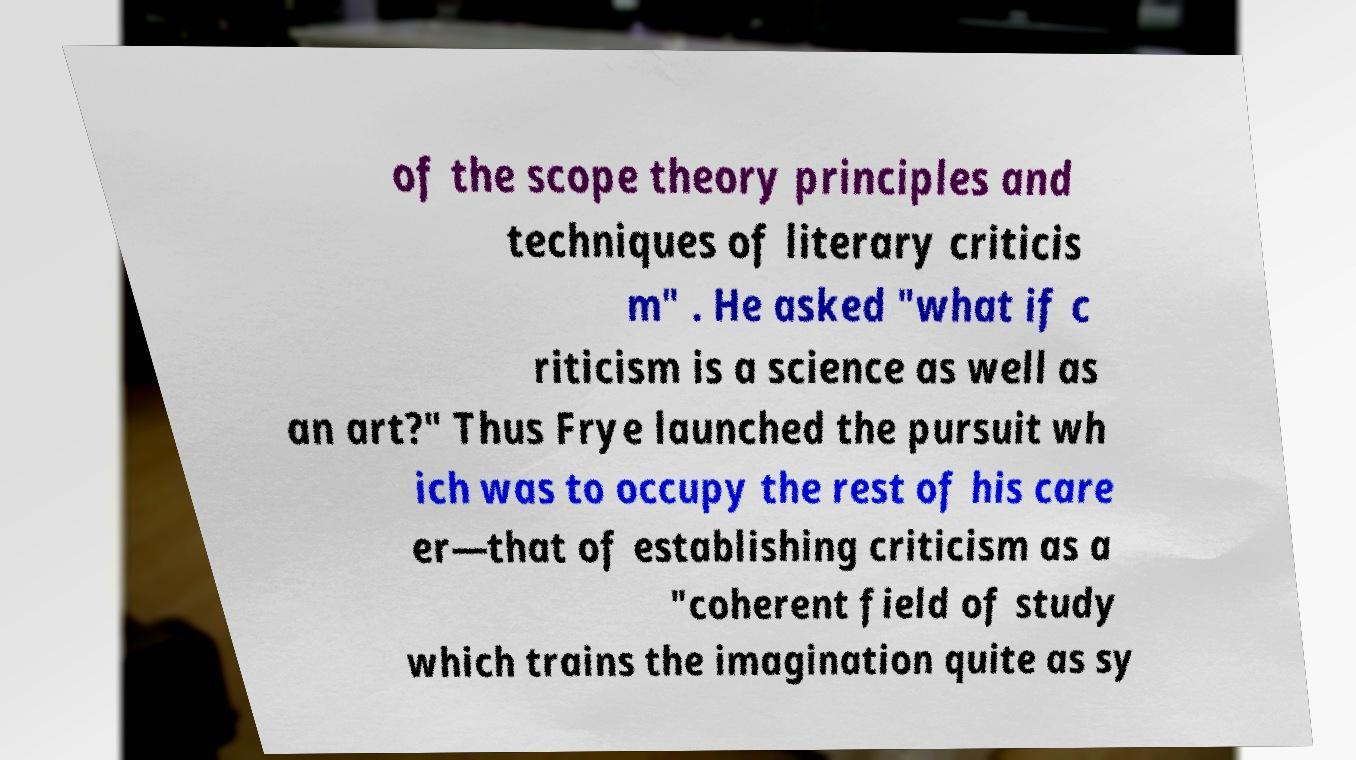Can you read and provide the text displayed in the image?This photo seems to have some interesting text. Can you extract and type it out for me? of the scope theory principles and techniques of literary criticis m" . He asked "what if c riticism is a science as well as an art?" Thus Frye launched the pursuit wh ich was to occupy the rest of his care er—that of establishing criticism as a "coherent field of study which trains the imagination quite as sy 